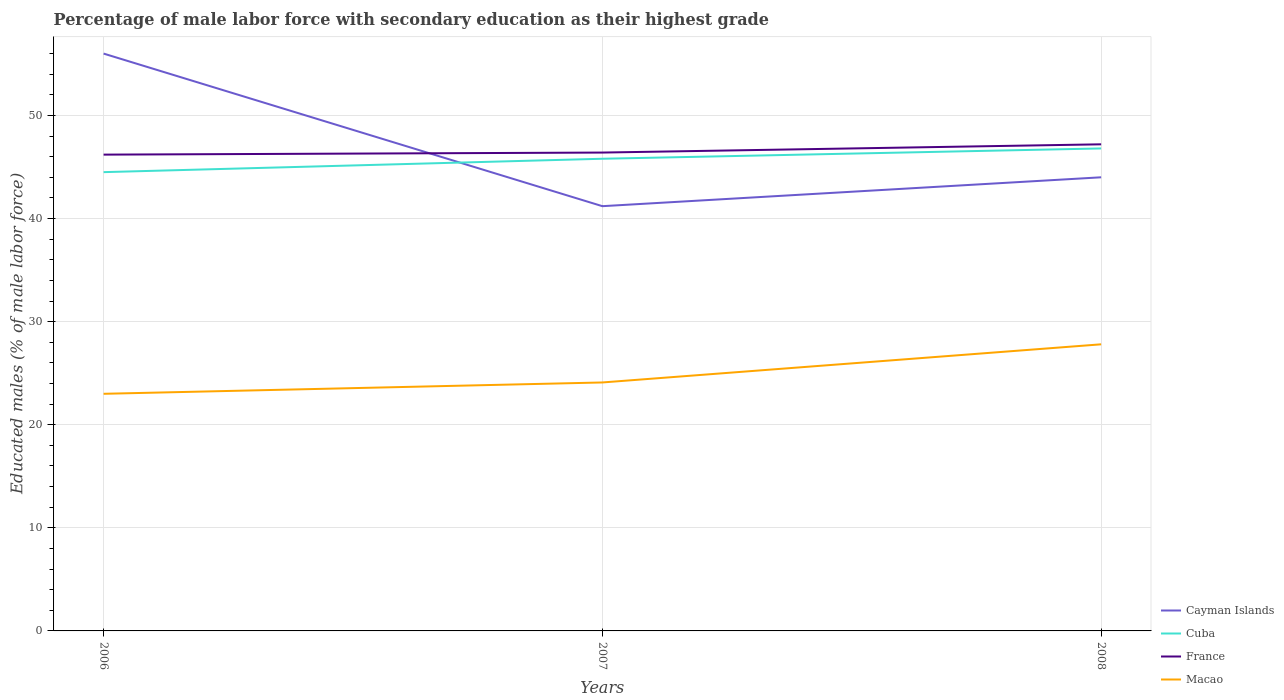How many different coloured lines are there?
Ensure brevity in your answer.  4. Does the line corresponding to France intersect with the line corresponding to Macao?
Make the answer very short. No. Is the number of lines equal to the number of legend labels?
Provide a succinct answer. Yes. What is the total percentage of male labor force with secondary education in Cuba in the graph?
Your answer should be compact. -2.3. What is the difference between the highest and the second highest percentage of male labor force with secondary education in Cuba?
Offer a very short reply. 2.3. What is the difference between the highest and the lowest percentage of male labor force with secondary education in France?
Provide a short and direct response. 1. How many lines are there?
Your answer should be very brief. 4. Does the graph contain any zero values?
Give a very brief answer. No. Does the graph contain grids?
Provide a short and direct response. Yes. Where does the legend appear in the graph?
Provide a succinct answer. Bottom right. What is the title of the graph?
Your answer should be very brief. Percentage of male labor force with secondary education as their highest grade. What is the label or title of the Y-axis?
Provide a succinct answer. Educated males (% of male labor force). What is the Educated males (% of male labor force) of Cuba in 2006?
Keep it short and to the point. 44.5. What is the Educated males (% of male labor force) in France in 2006?
Give a very brief answer. 46.2. What is the Educated males (% of male labor force) in Macao in 2006?
Provide a succinct answer. 23. What is the Educated males (% of male labor force) in Cayman Islands in 2007?
Your answer should be compact. 41.2. What is the Educated males (% of male labor force) of Cuba in 2007?
Your answer should be compact. 45.8. What is the Educated males (% of male labor force) in France in 2007?
Make the answer very short. 46.4. What is the Educated males (% of male labor force) of Macao in 2007?
Make the answer very short. 24.1. What is the Educated males (% of male labor force) of Cayman Islands in 2008?
Give a very brief answer. 44. What is the Educated males (% of male labor force) in Cuba in 2008?
Offer a terse response. 46.8. What is the Educated males (% of male labor force) of France in 2008?
Provide a short and direct response. 47.2. What is the Educated males (% of male labor force) in Macao in 2008?
Your answer should be very brief. 27.8. Across all years, what is the maximum Educated males (% of male labor force) in Cuba?
Provide a short and direct response. 46.8. Across all years, what is the maximum Educated males (% of male labor force) of France?
Your response must be concise. 47.2. Across all years, what is the maximum Educated males (% of male labor force) of Macao?
Make the answer very short. 27.8. Across all years, what is the minimum Educated males (% of male labor force) of Cayman Islands?
Provide a succinct answer. 41.2. Across all years, what is the minimum Educated males (% of male labor force) in Cuba?
Your response must be concise. 44.5. Across all years, what is the minimum Educated males (% of male labor force) in France?
Offer a very short reply. 46.2. What is the total Educated males (% of male labor force) of Cayman Islands in the graph?
Ensure brevity in your answer.  141.2. What is the total Educated males (% of male labor force) in Cuba in the graph?
Ensure brevity in your answer.  137.1. What is the total Educated males (% of male labor force) of France in the graph?
Make the answer very short. 139.8. What is the total Educated males (% of male labor force) in Macao in the graph?
Ensure brevity in your answer.  74.9. What is the difference between the Educated males (% of male labor force) in Cayman Islands in 2006 and that in 2007?
Make the answer very short. 14.8. What is the difference between the Educated males (% of male labor force) in France in 2006 and that in 2007?
Offer a very short reply. -0.2. What is the difference between the Educated males (% of male labor force) of Cuba in 2006 and that in 2008?
Your answer should be very brief. -2.3. What is the difference between the Educated males (% of male labor force) in Cayman Islands in 2007 and that in 2008?
Offer a terse response. -2.8. What is the difference between the Educated males (% of male labor force) in Cayman Islands in 2006 and the Educated males (% of male labor force) in Macao in 2007?
Provide a succinct answer. 31.9. What is the difference between the Educated males (% of male labor force) of Cuba in 2006 and the Educated males (% of male labor force) of France in 2007?
Your answer should be very brief. -1.9. What is the difference between the Educated males (% of male labor force) in Cuba in 2006 and the Educated males (% of male labor force) in Macao in 2007?
Your response must be concise. 20.4. What is the difference between the Educated males (% of male labor force) in France in 2006 and the Educated males (% of male labor force) in Macao in 2007?
Your response must be concise. 22.1. What is the difference between the Educated males (% of male labor force) in Cayman Islands in 2006 and the Educated males (% of male labor force) in Macao in 2008?
Provide a succinct answer. 28.2. What is the difference between the Educated males (% of male labor force) in Cuba in 2006 and the Educated males (% of male labor force) in France in 2008?
Keep it short and to the point. -2.7. What is the difference between the Educated males (% of male labor force) in Cayman Islands in 2007 and the Educated males (% of male labor force) in France in 2008?
Offer a very short reply. -6. What is the difference between the Educated males (% of male labor force) of Cayman Islands in 2007 and the Educated males (% of male labor force) of Macao in 2008?
Keep it short and to the point. 13.4. What is the difference between the Educated males (% of male labor force) of Cuba in 2007 and the Educated males (% of male labor force) of France in 2008?
Keep it short and to the point. -1.4. What is the difference between the Educated males (% of male labor force) of Cuba in 2007 and the Educated males (% of male labor force) of Macao in 2008?
Offer a terse response. 18. What is the average Educated males (% of male labor force) of Cayman Islands per year?
Give a very brief answer. 47.07. What is the average Educated males (% of male labor force) of Cuba per year?
Give a very brief answer. 45.7. What is the average Educated males (% of male labor force) of France per year?
Make the answer very short. 46.6. What is the average Educated males (% of male labor force) of Macao per year?
Offer a terse response. 24.97. In the year 2006, what is the difference between the Educated males (% of male labor force) in Cuba and Educated males (% of male labor force) in France?
Make the answer very short. -1.7. In the year 2006, what is the difference between the Educated males (% of male labor force) of France and Educated males (% of male labor force) of Macao?
Give a very brief answer. 23.2. In the year 2007, what is the difference between the Educated males (% of male labor force) of Cayman Islands and Educated males (% of male labor force) of Cuba?
Keep it short and to the point. -4.6. In the year 2007, what is the difference between the Educated males (% of male labor force) in Cayman Islands and Educated males (% of male labor force) in France?
Offer a terse response. -5.2. In the year 2007, what is the difference between the Educated males (% of male labor force) in Cayman Islands and Educated males (% of male labor force) in Macao?
Offer a very short reply. 17.1. In the year 2007, what is the difference between the Educated males (% of male labor force) of Cuba and Educated males (% of male labor force) of France?
Provide a short and direct response. -0.6. In the year 2007, what is the difference between the Educated males (% of male labor force) in Cuba and Educated males (% of male labor force) in Macao?
Give a very brief answer. 21.7. In the year 2007, what is the difference between the Educated males (% of male labor force) in France and Educated males (% of male labor force) in Macao?
Provide a short and direct response. 22.3. In the year 2008, what is the difference between the Educated males (% of male labor force) of Cayman Islands and Educated males (% of male labor force) of Cuba?
Keep it short and to the point. -2.8. In the year 2008, what is the difference between the Educated males (% of male labor force) in France and Educated males (% of male labor force) in Macao?
Provide a succinct answer. 19.4. What is the ratio of the Educated males (% of male labor force) of Cayman Islands in 2006 to that in 2007?
Keep it short and to the point. 1.36. What is the ratio of the Educated males (% of male labor force) in Cuba in 2006 to that in 2007?
Keep it short and to the point. 0.97. What is the ratio of the Educated males (% of male labor force) of France in 2006 to that in 2007?
Keep it short and to the point. 1. What is the ratio of the Educated males (% of male labor force) of Macao in 2006 to that in 2007?
Your answer should be compact. 0.95. What is the ratio of the Educated males (% of male labor force) in Cayman Islands in 2006 to that in 2008?
Provide a short and direct response. 1.27. What is the ratio of the Educated males (% of male labor force) in Cuba in 2006 to that in 2008?
Provide a succinct answer. 0.95. What is the ratio of the Educated males (% of male labor force) in France in 2006 to that in 2008?
Your answer should be very brief. 0.98. What is the ratio of the Educated males (% of male labor force) of Macao in 2006 to that in 2008?
Offer a terse response. 0.83. What is the ratio of the Educated males (% of male labor force) in Cayman Islands in 2007 to that in 2008?
Provide a short and direct response. 0.94. What is the ratio of the Educated males (% of male labor force) of Cuba in 2007 to that in 2008?
Make the answer very short. 0.98. What is the ratio of the Educated males (% of male labor force) of France in 2007 to that in 2008?
Offer a very short reply. 0.98. What is the ratio of the Educated males (% of male labor force) in Macao in 2007 to that in 2008?
Provide a short and direct response. 0.87. What is the difference between the highest and the second highest Educated males (% of male labor force) of France?
Make the answer very short. 0.8. What is the difference between the highest and the lowest Educated males (% of male labor force) of Cayman Islands?
Your answer should be very brief. 14.8. 